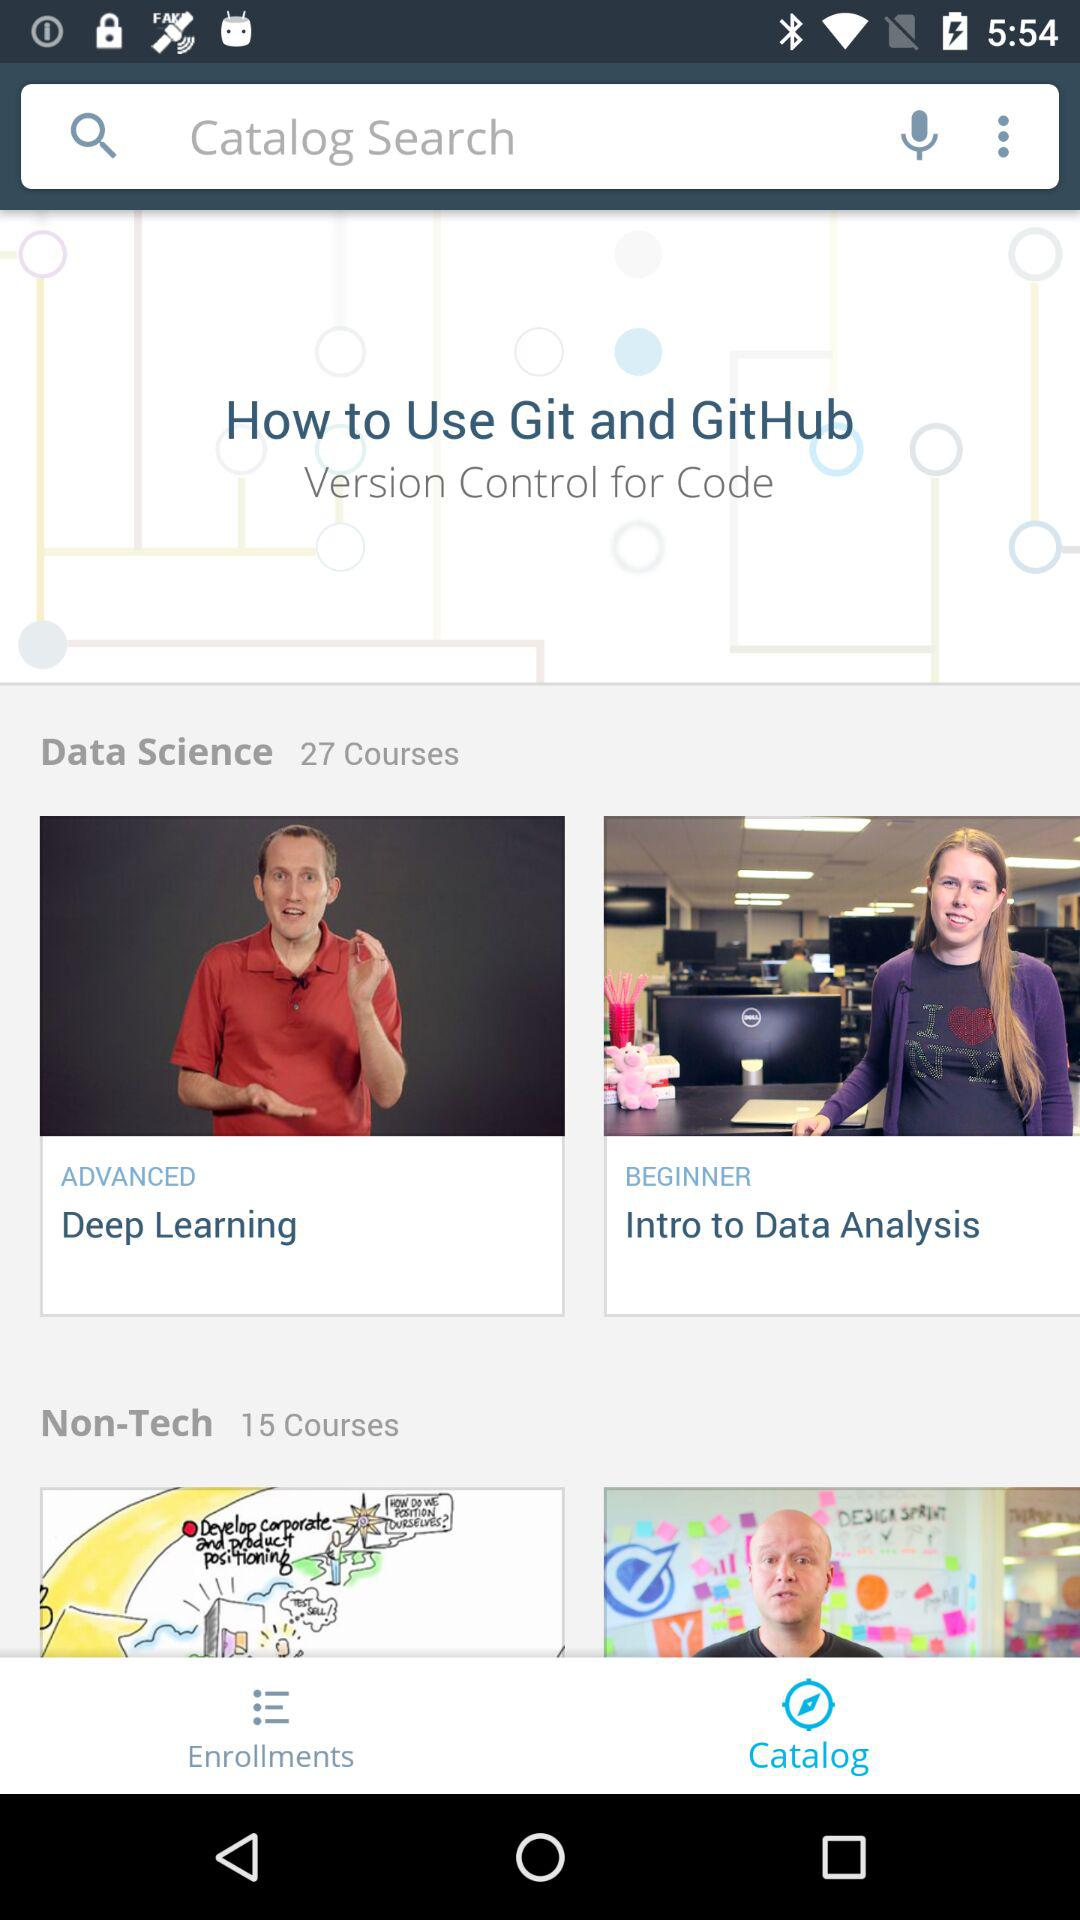How many data science courses are available? The number of available data science courses is 27. 